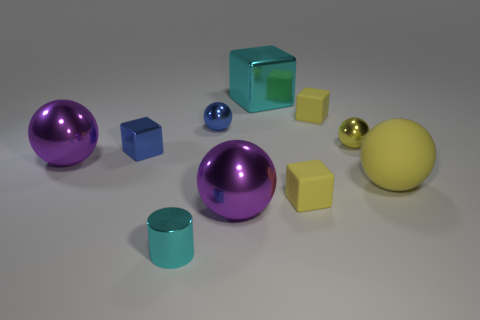Subtract all blue spheres. Subtract all red cylinders. How many spheres are left? 4 Subtract all cubes. How many objects are left? 6 Add 6 big cyan shiny cubes. How many big cyan shiny cubes exist? 7 Subtract 0 gray cylinders. How many objects are left? 10 Subtract all shiny balls. Subtract all rubber spheres. How many objects are left? 5 Add 4 big rubber spheres. How many big rubber spheres are left? 5 